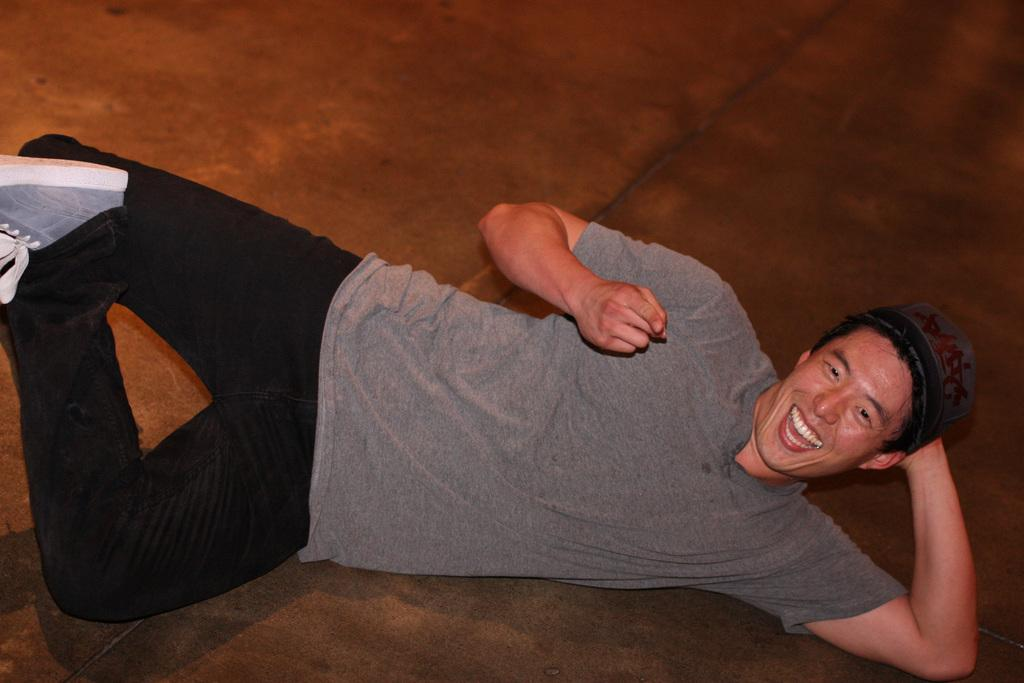What is the main subject of the image? The main subject of the image is a man. Can you describe what the man is wearing? The man is wearing a cap and a t-shirt. What is the man's facial expression in the image? The man is smiling. What is the man's position in the image? The man is lying on the floor. What type of dog can be seen playing with a drink near the mailbox in the image? There is no dog, drink, or mailbox present in the image. 